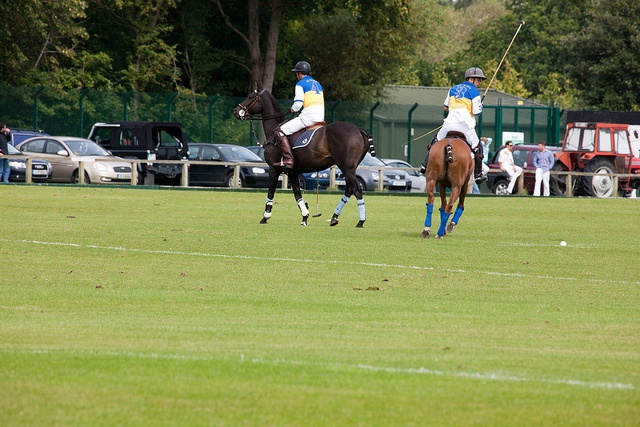Describe the objects in this image and their specific colors. I can see horse in black, gray, maroon, and white tones, truck in black, lightgray, gray, and darkgray tones, car in black, gray, and blue tones, car in black, lightgray, darkgray, and gray tones, and horse in black, brown, and maroon tones in this image. 